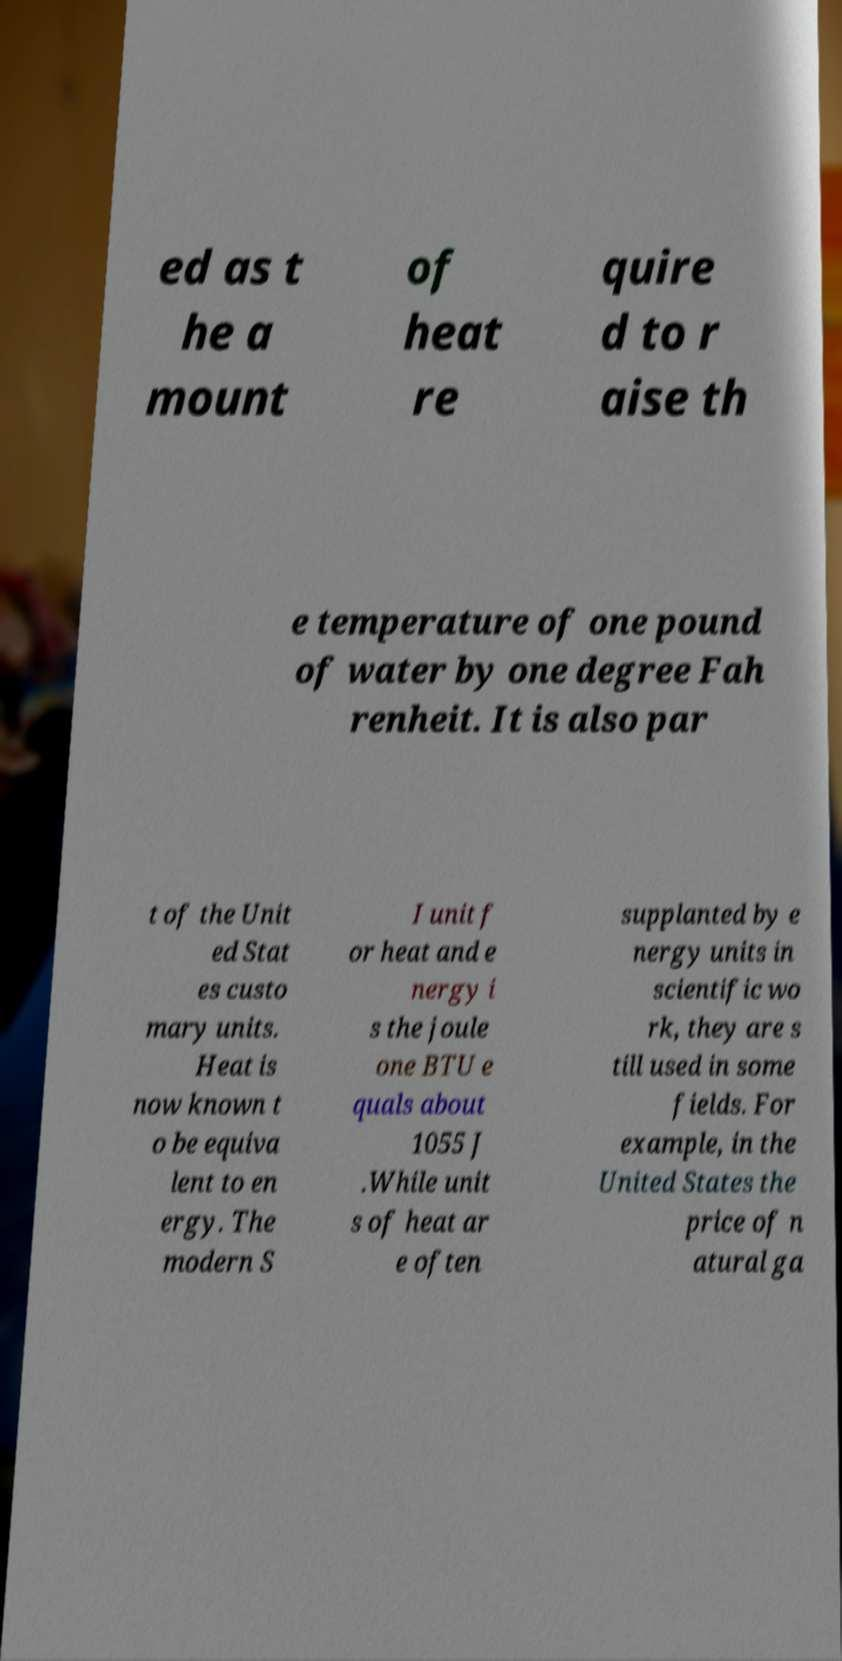There's text embedded in this image that I need extracted. Can you transcribe it verbatim? ed as t he a mount of heat re quire d to r aise th e temperature of one pound of water by one degree Fah renheit. It is also par t of the Unit ed Stat es custo mary units. Heat is now known t o be equiva lent to en ergy. The modern S I unit f or heat and e nergy i s the joule one BTU e quals about 1055 J .While unit s of heat ar e often supplanted by e nergy units in scientific wo rk, they are s till used in some fields. For example, in the United States the price of n atural ga 